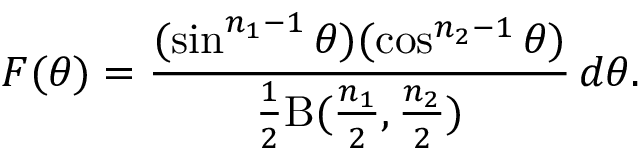Convert formula to latex. <formula><loc_0><loc_0><loc_500><loc_500>F ( \theta ) = { \frac { ( \sin ^ { n _ { 1 } - 1 } \theta ) ( \cos ^ { n _ { 2 } - 1 } \theta ) } { { \frac { 1 } { 2 } } B ( { \frac { n _ { 1 } } { 2 } } , { \frac { n _ { 2 } } { 2 } } ) } } \, d \theta .</formula> 